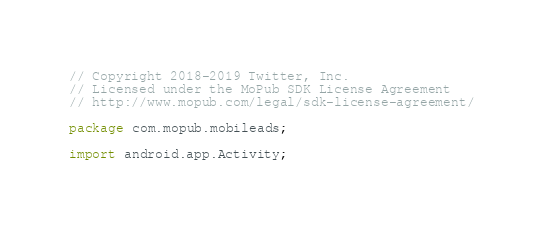<code> <loc_0><loc_0><loc_500><loc_500><_Java_>// Copyright 2018-2019 Twitter, Inc.
// Licensed under the MoPub SDK License Agreement
// http://www.mopub.com/legal/sdk-license-agreement/

package com.mopub.mobileads;

import android.app.Activity;</code> 